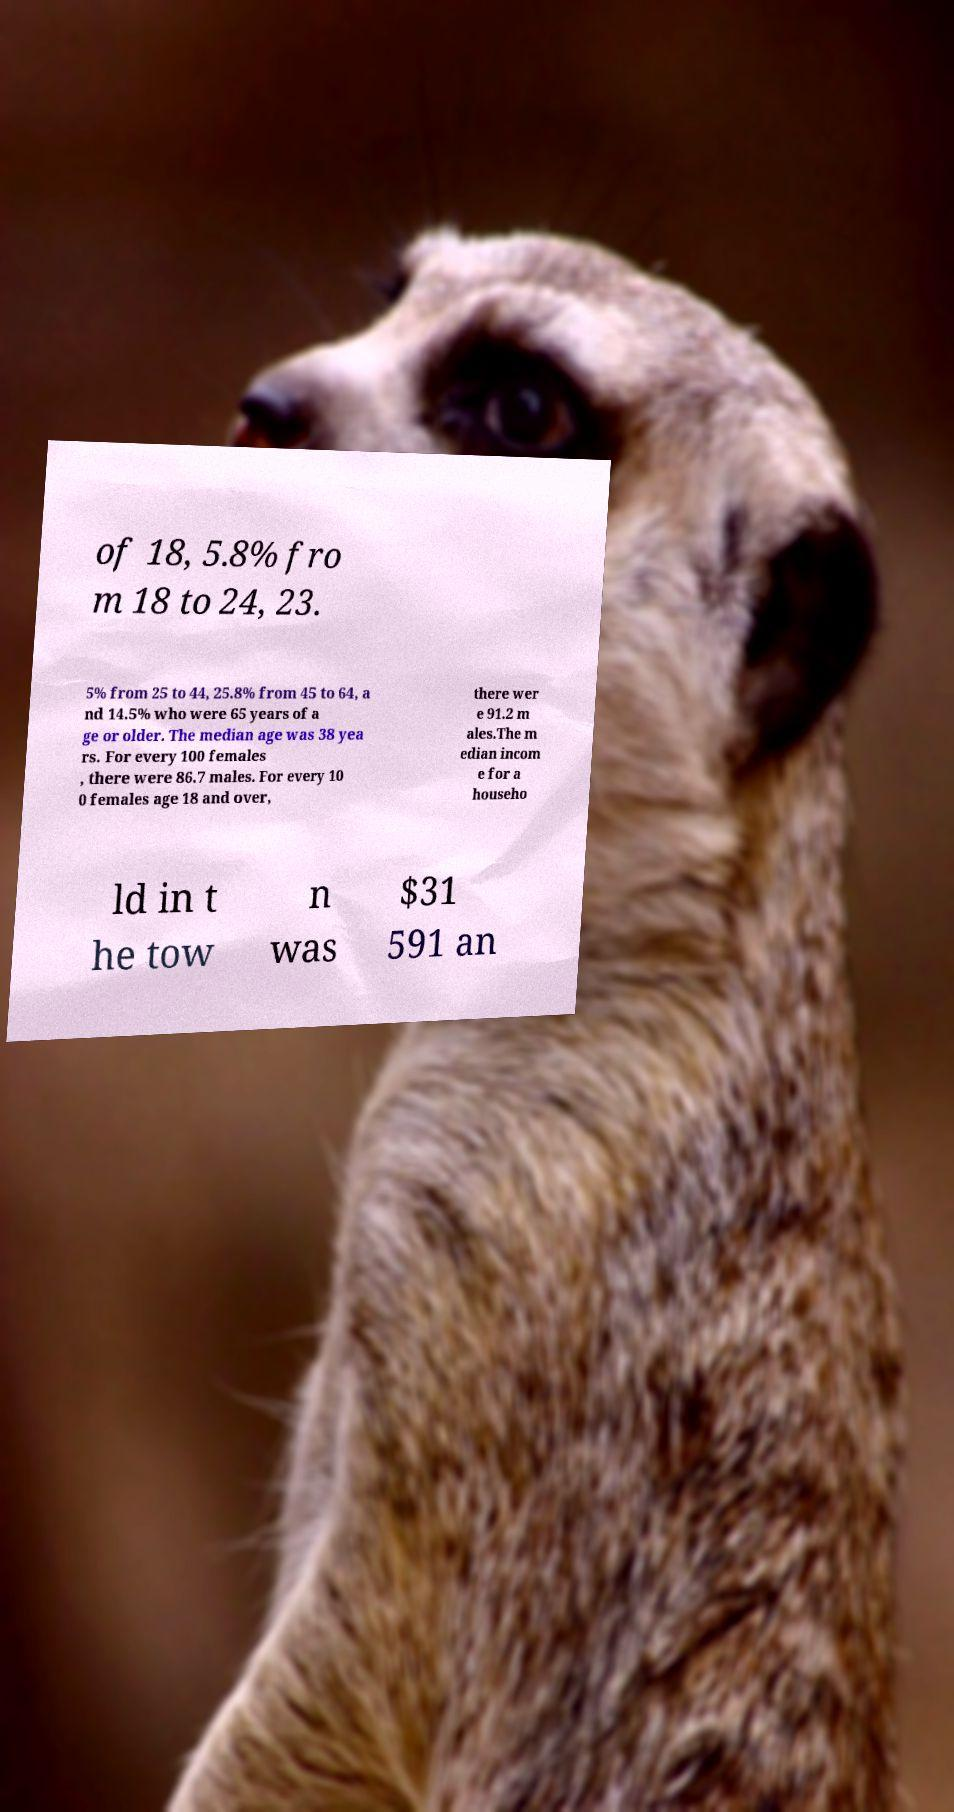I need the written content from this picture converted into text. Can you do that? of 18, 5.8% fro m 18 to 24, 23. 5% from 25 to 44, 25.8% from 45 to 64, a nd 14.5% who were 65 years of a ge or older. The median age was 38 yea rs. For every 100 females , there were 86.7 males. For every 10 0 females age 18 and over, there wer e 91.2 m ales.The m edian incom e for a househo ld in t he tow n was $31 591 an 